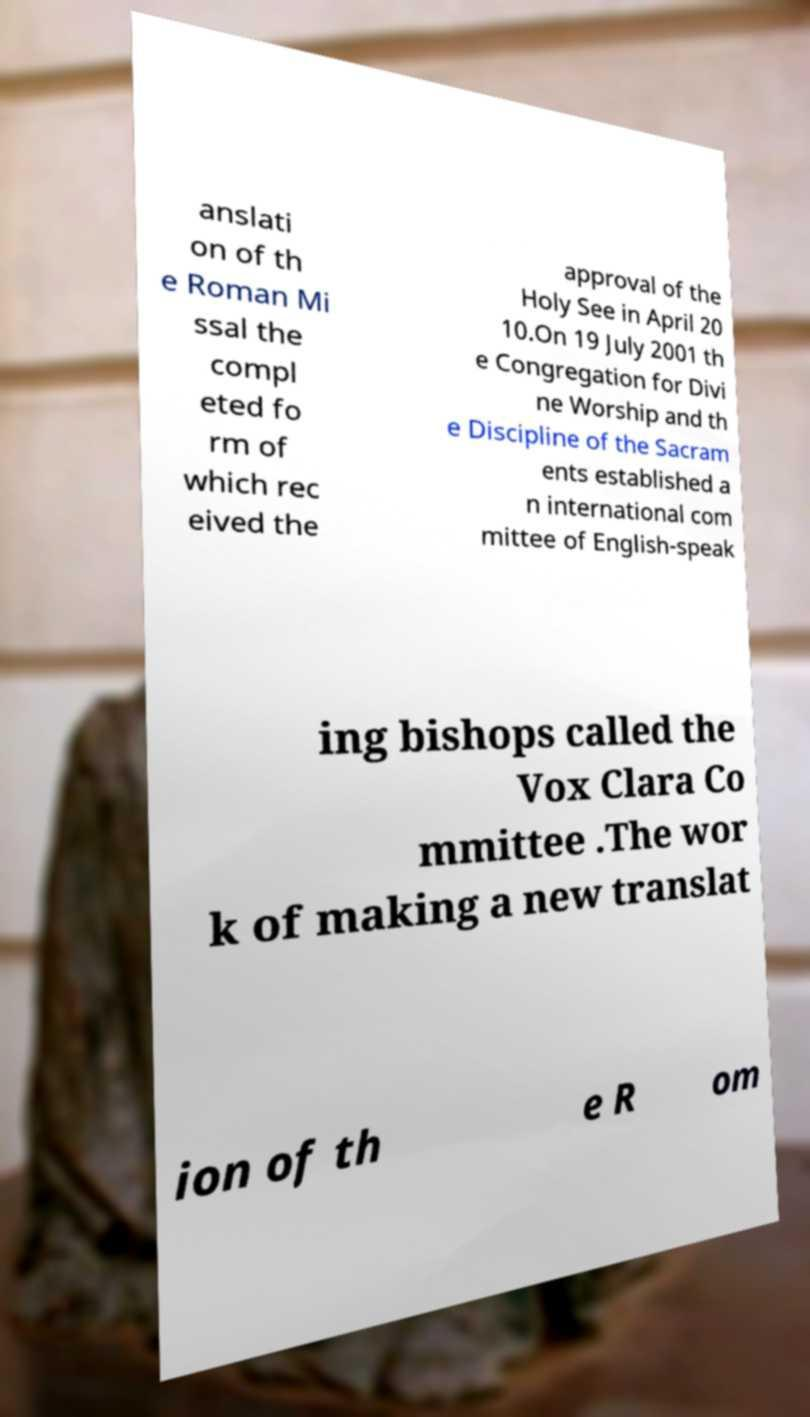Could you assist in decoding the text presented in this image and type it out clearly? anslati on of th e Roman Mi ssal the compl eted fo rm of which rec eived the approval of the Holy See in April 20 10.On 19 July 2001 th e Congregation for Divi ne Worship and th e Discipline of the Sacram ents established a n international com mittee of English-speak ing bishops called the Vox Clara Co mmittee .The wor k of making a new translat ion of th e R om 